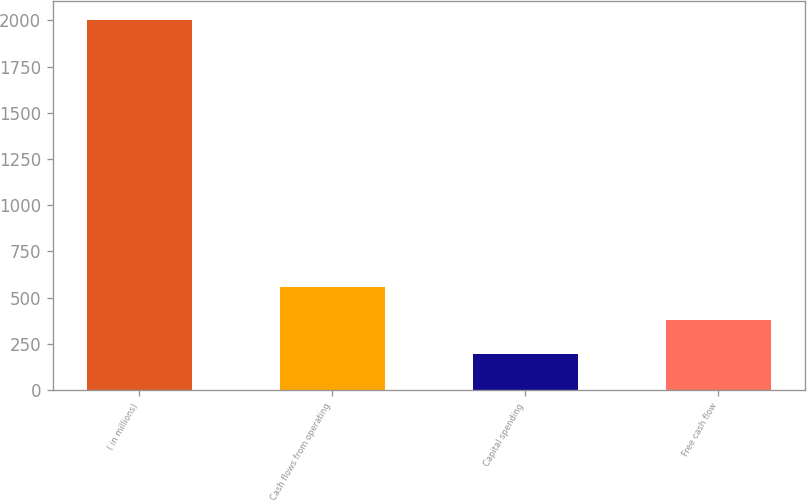Convert chart. <chart><loc_0><loc_0><loc_500><loc_500><bar_chart><fcel>( in millions)<fcel>Cash flows from operating<fcel>Capital spending<fcel>Free cash flow<nl><fcel>2004<fcel>557.6<fcel>196<fcel>376.8<nl></chart> 